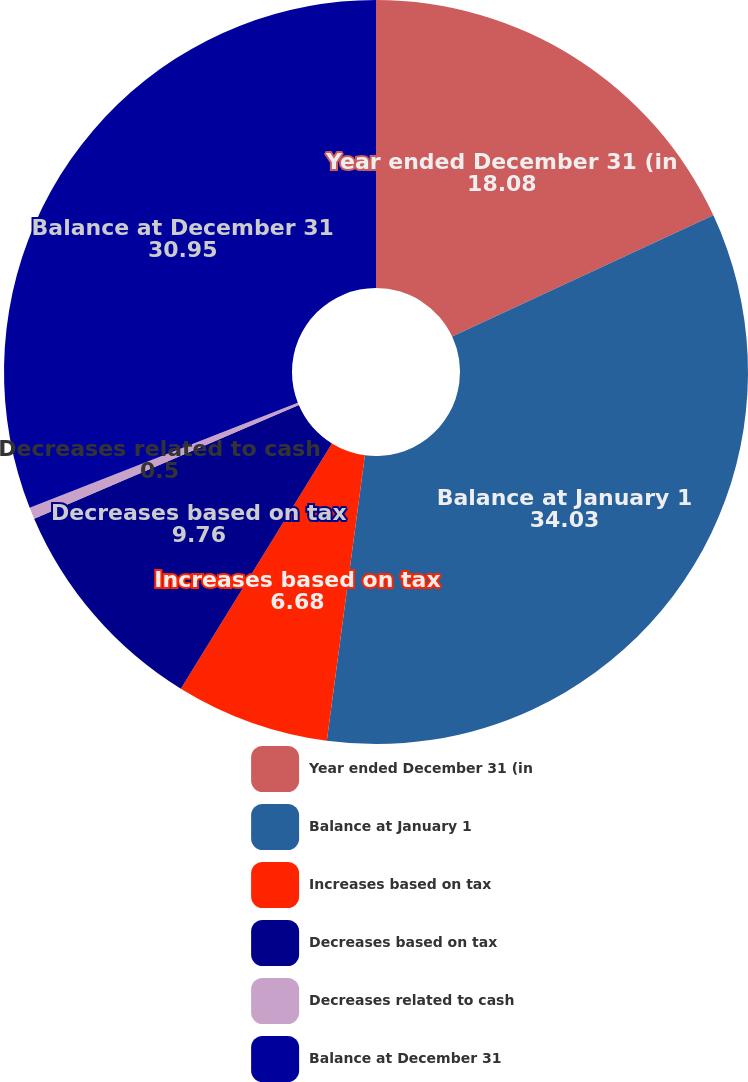Convert chart to OTSL. <chart><loc_0><loc_0><loc_500><loc_500><pie_chart><fcel>Year ended December 31 (in<fcel>Balance at January 1<fcel>Increases based on tax<fcel>Decreases based on tax<fcel>Decreases related to cash<fcel>Balance at December 31<nl><fcel>18.08%<fcel>34.03%<fcel>6.68%<fcel>9.76%<fcel>0.5%<fcel>30.95%<nl></chart> 